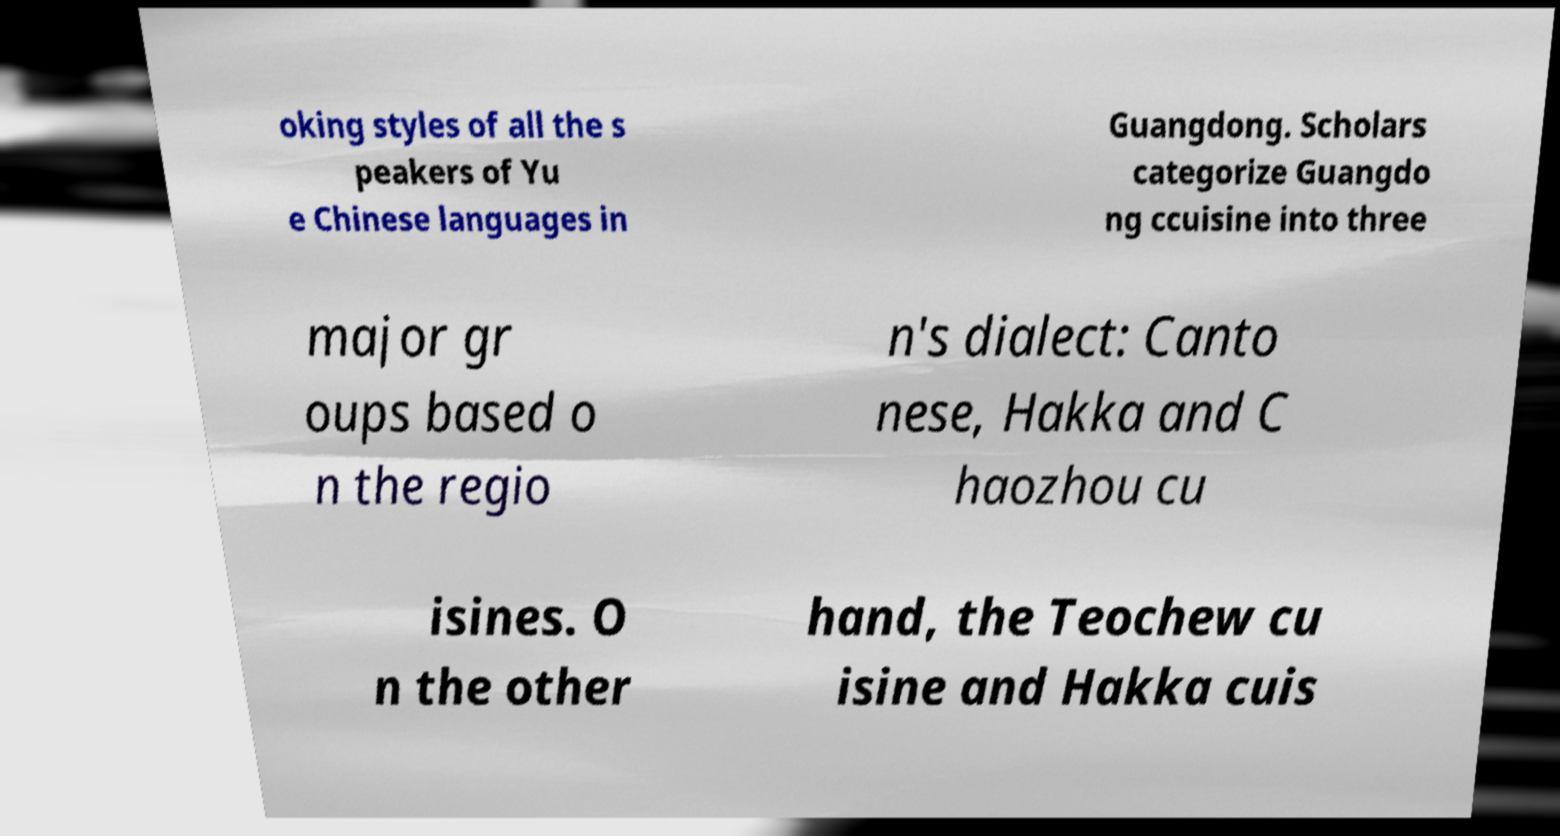Please identify and transcribe the text found in this image. oking styles of all the s peakers of Yu e Chinese languages in Guangdong. Scholars categorize Guangdo ng ccuisine into three major gr oups based o n the regio n's dialect: Canto nese, Hakka and C haozhou cu isines. O n the other hand, the Teochew cu isine and Hakka cuis 